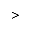<formula> <loc_0><loc_0><loc_500><loc_500>></formula> 